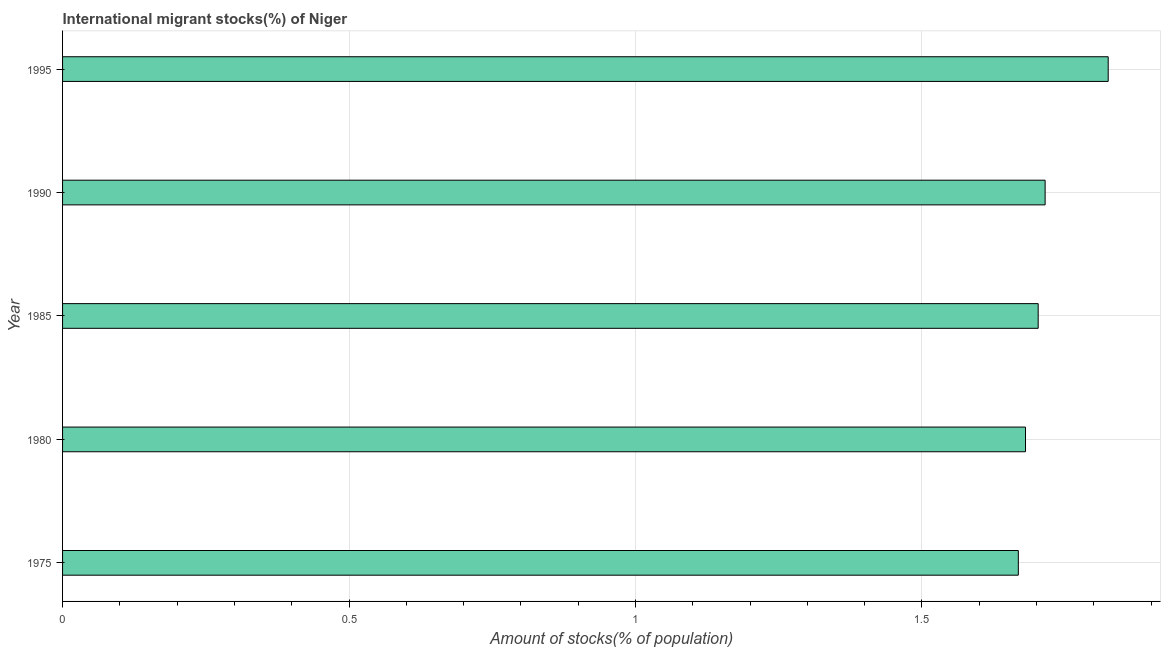What is the title of the graph?
Offer a terse response. International migrant stocks(%) of Niger. What is the label or title of the X-axis?
Ensure brevity in your answer.  Amount of stocks(% of population). What is the label or title of the Y-axis?
Your answer should be compact. Year. What is the number of international migrant stocks in 1975?
Make the answer very short. 1.67. Across all years, what is the maximum number of international migrant stocks?
Offer a terse response. 1.83. Across all years, what is the minimum number of international migrant stocks?
Make the answer very short. 1.67. In which year was the number of international migrant stocks minimum?
Offer a terse response. 1975. What is the sum of the number of international migrant stocks?
Provide a short and direct response. 8.59. What is the difference between the number of international migrant stocks in 1975 and 1985?
Make the answer very short. -0.04. What is the average number of international migrant stocks per year?
Give a very brief answer. 1.72. What is the median number of international migrant stocks?
Your answer should be very brief. 1.7. In how many years, is the number of international migrant stocks greater than 0.6 %?
Your response must be concise. 5. Is the difference between the number of international migrant stocks in 1985 and 1995 greater than the difference between any two years?
Provide a short and direct response. No. What is the difference between the highest and the second highest number of international migrant stocks?
Provide a short and direct response. 0.11. What is the difference between the highest and the lowest number of international migrant stocks?
Keep it short and to the point. 0.16. How many bars are there?
Your answer should be very brief. 5. What is the Amount of stocks(% of population) of 1975?
Offer a very short reply. 1.67. What is the Amount of stocks(% of population) in 1980?
Provide a succinct answer. 1.68. What is the Amount of stocks(% of population) of 1985?
Your response must be concise. 1.7. What is the Amount of stocks(% of population) of 1990?
Provide a short and direct response. 1.72. What is the Amount of stocks(% of population) in 1995?
Keep it short and to the point. 1.83. What is the difference between the Amount of stocks(% of population) in 1975 and 1980?
Your answer should be very brief. -0.01. What is the difference between the Amount of stocks(% of population) in 1975 and 1985?
Ensure brevity in your answer.  -0.03. What is the difference between the Amount of stocks(% of population) in 1975 and 1990?
Provide a succinct answer. -0.05. What is the difference between the Amount of stocks(% of population) in 1975 and 1995?
Ensure brevity in your answer.  -0.16. What is the difference between the Amount of stocks(% of population) in 1980 and 1985?
Your response must be concise. -0.02. What is the difference between the Amount of stocks(% of population) in 1980 and 1990?
Offer a terse response. -0.03. What is the difference between the Amount of stocks(% of population) in 1980 and 1995?
Offer a terse response. -0.14. What is the difference between the Amount of stocks(% of population) in 1985 and 1990?
Offer a terse response. -0.01. What is the difference between the Amount of stocks(% of population) in 1985 and 1995?
Keep it short and to the point. -0.12. What is the difference between the Amount of stocks(% of population) in 1990 and 1995?
Provide a succinct answer. -0.11. What is the ratio of the Amount of stocks(% of population) in 1975 to that in 1985?
Provide a short and direct response. 0.98. What is the ratio of the Amount of stocks(% of population) in 1975 to that in 1995?
Keep it short and to the point. 0.91. What is the ratio of the Amount of stocks(% of population) in 1980 to that in 1985?
Your response must be concise. 0.99. What is the ratio of the Amount of stocks(% of population) in 1980 to that in 1995?
Provide a short and direct response. 0.92. What is the ratio of the Amount of stocks(% of population) in 1985 to that in 1990?
Your answer should be very brief. 0.99. What is the ratio of the Amount of stocks(% of population) in 1985 to that in 1995?
Offer a very short reply. 0.93. What is the ratio of the Amount of stocks(% of population) in 1990 to that in 1995?
Ensure brevity in your answer.  0.94. 